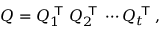<formula> <loc_0><loc_0><loc_500><loc_500>Q = Q _ { 1 } ^ { T } Q _ { 2 } ^ { T } \cdots Q _ { t } ^ { T } ,</formula> 